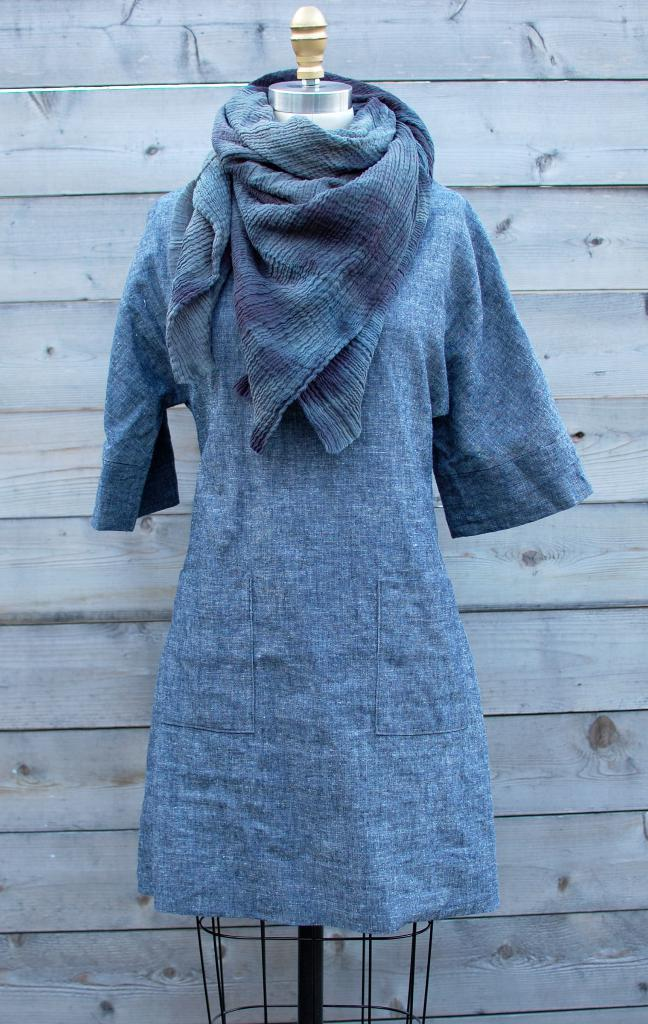What type of clothing item is in the image? There is a dress in the image. Where is the dress located? The dress is on a mannequin. What color is the dress? The dress is blue in color. What can be seen in the background of the image? There is a wooden wall in the background of the image. How does the bread balance on the boy's head in the image? There is no bread or boy present in the image; it only features a dress on a mannequin and a wooden wall in the background. 